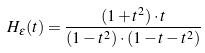Convert formula to latex. <formula><loc_0><loc_0><loc_500><loc_500>H _ { \epsilon } ( t ) = \frac { ( 1 + t ^ { 2 } ) \cdot t } { ( 1 - t ^ { 2 } ) \cdot ( 1 - t - t ^ { 2 } ) }</formula> 